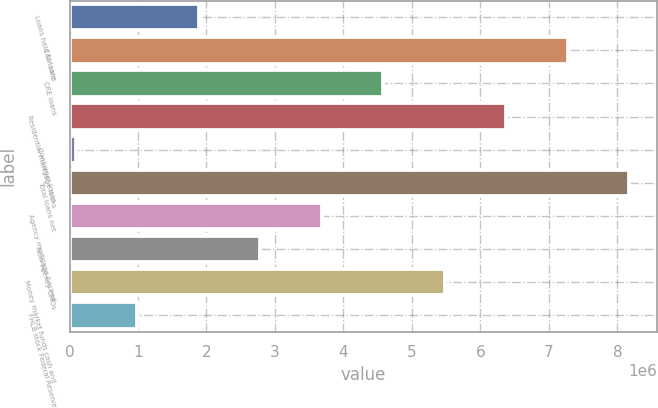Convert chart to OTSL. <chart><loc_0><loc_0><loc_500><loc_500><bar_chart><fcel>Loans held for sale<fcel>C&I loans<fcel>CRE loans<fcel>Residential mortgage loans<fcel>Consumer loans<fcel>Total loans net<fcel>Agency mortgage-backed<fcel>Non-agency CMOs<fcel>Money market funds cash and<fcel>FHLB stock Federal Reserve<nl><fcel>1.88511e+06<fcel>7.27551e+06<fcel>4.58031e+06<fcel>6.37711e+06<fcel>88310<fcel>8.17391e+06<fcel>3.68191e+06<fcel>2.78351e+06<fcel>5.47871e+06<fcel>986710<nl></chart> 